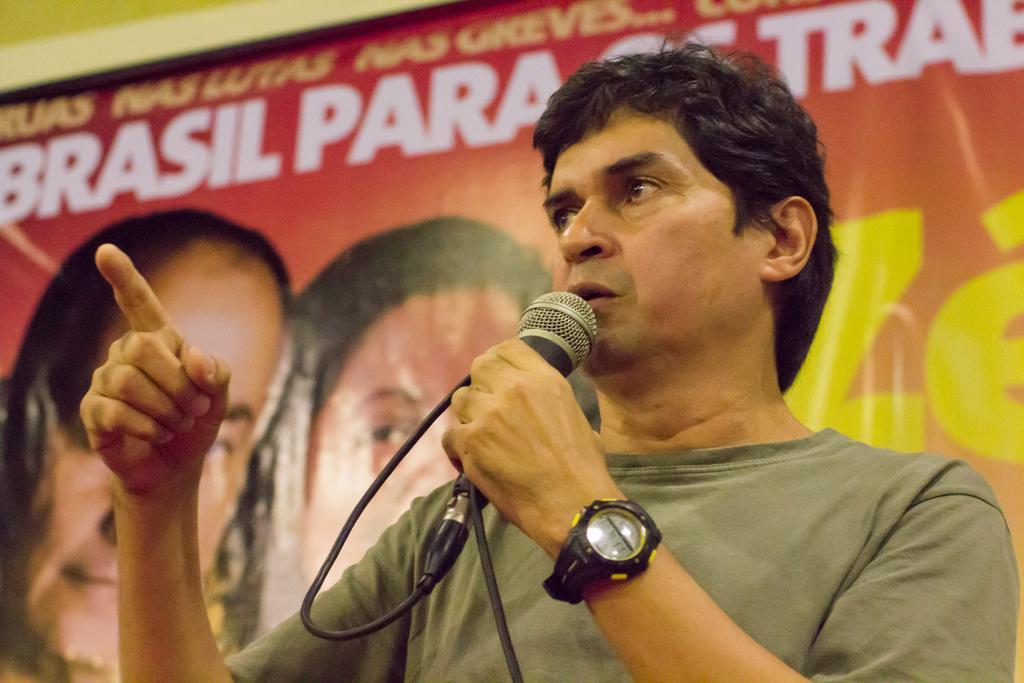Describe this image in one or two sentences. In the picture we can see a man talking in the microphone, a man who is talking in the microphone is wearing a green T-shirt, with wrist watch which is black in color. In the background we can the hoarding which consists of some persons and a name "BRASIL PARA TRAB." 